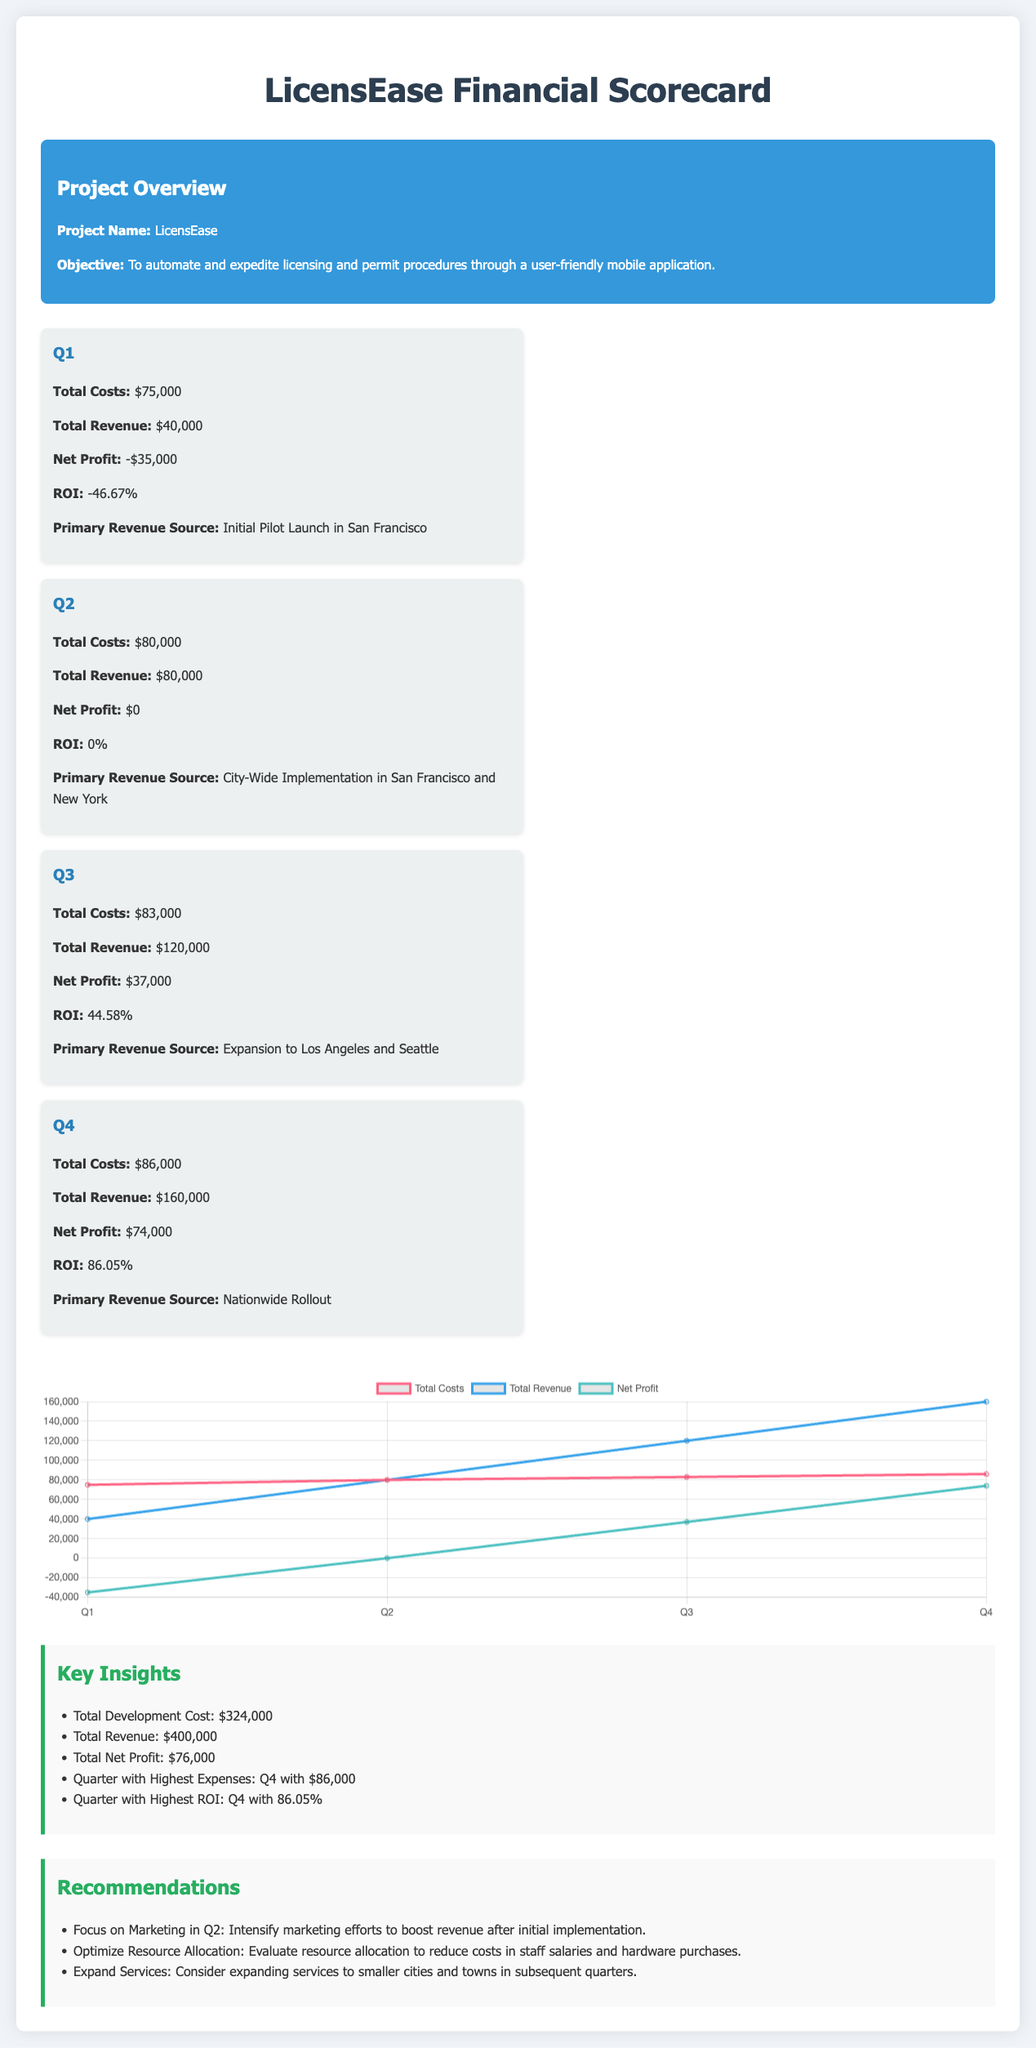What is the total development cost? The total development cost is provided as a key insight in the document, which sums up the costs for all quarters.
Answer: $324,000 What was the total revenue in Q3? The total revenue for Q3 is explicitly given in the financial breakdown section.
Answer: $120,000 What was the primary revenue source for Q1? The primary revenue source for Q1 is mentioned in the Q1 financial breakdown.
Answer: Initial Pilot Launch in San Francisco Which quarter had the highest expenses? The document specifies that Q4 had the highest expenses in the insights section.
Answer: Q4 What is the ROI for Q2? The ROI for Q2 is stated in the financial breakdown section.
Answer: 0% What was the net profit for Q4? The net profit for Q4 is provided in the financial breakdown section.
Answer: $74,000 Which quarter showed an overall net loss? The financial breakdown indicates which quarter had a net profit or loss.
Answer: Q1 What is the total revenue from all quarters combined? The total revenue is the sum of the revenues listed for each quarter in the financial breakdown.
Answer: $400,000 What recommendation is given for Q2? One of the recommendations specifically for Q2 is listed in the recommendations section.
Answer: Intensify marketing efforts to boost revenue after initial implementation 